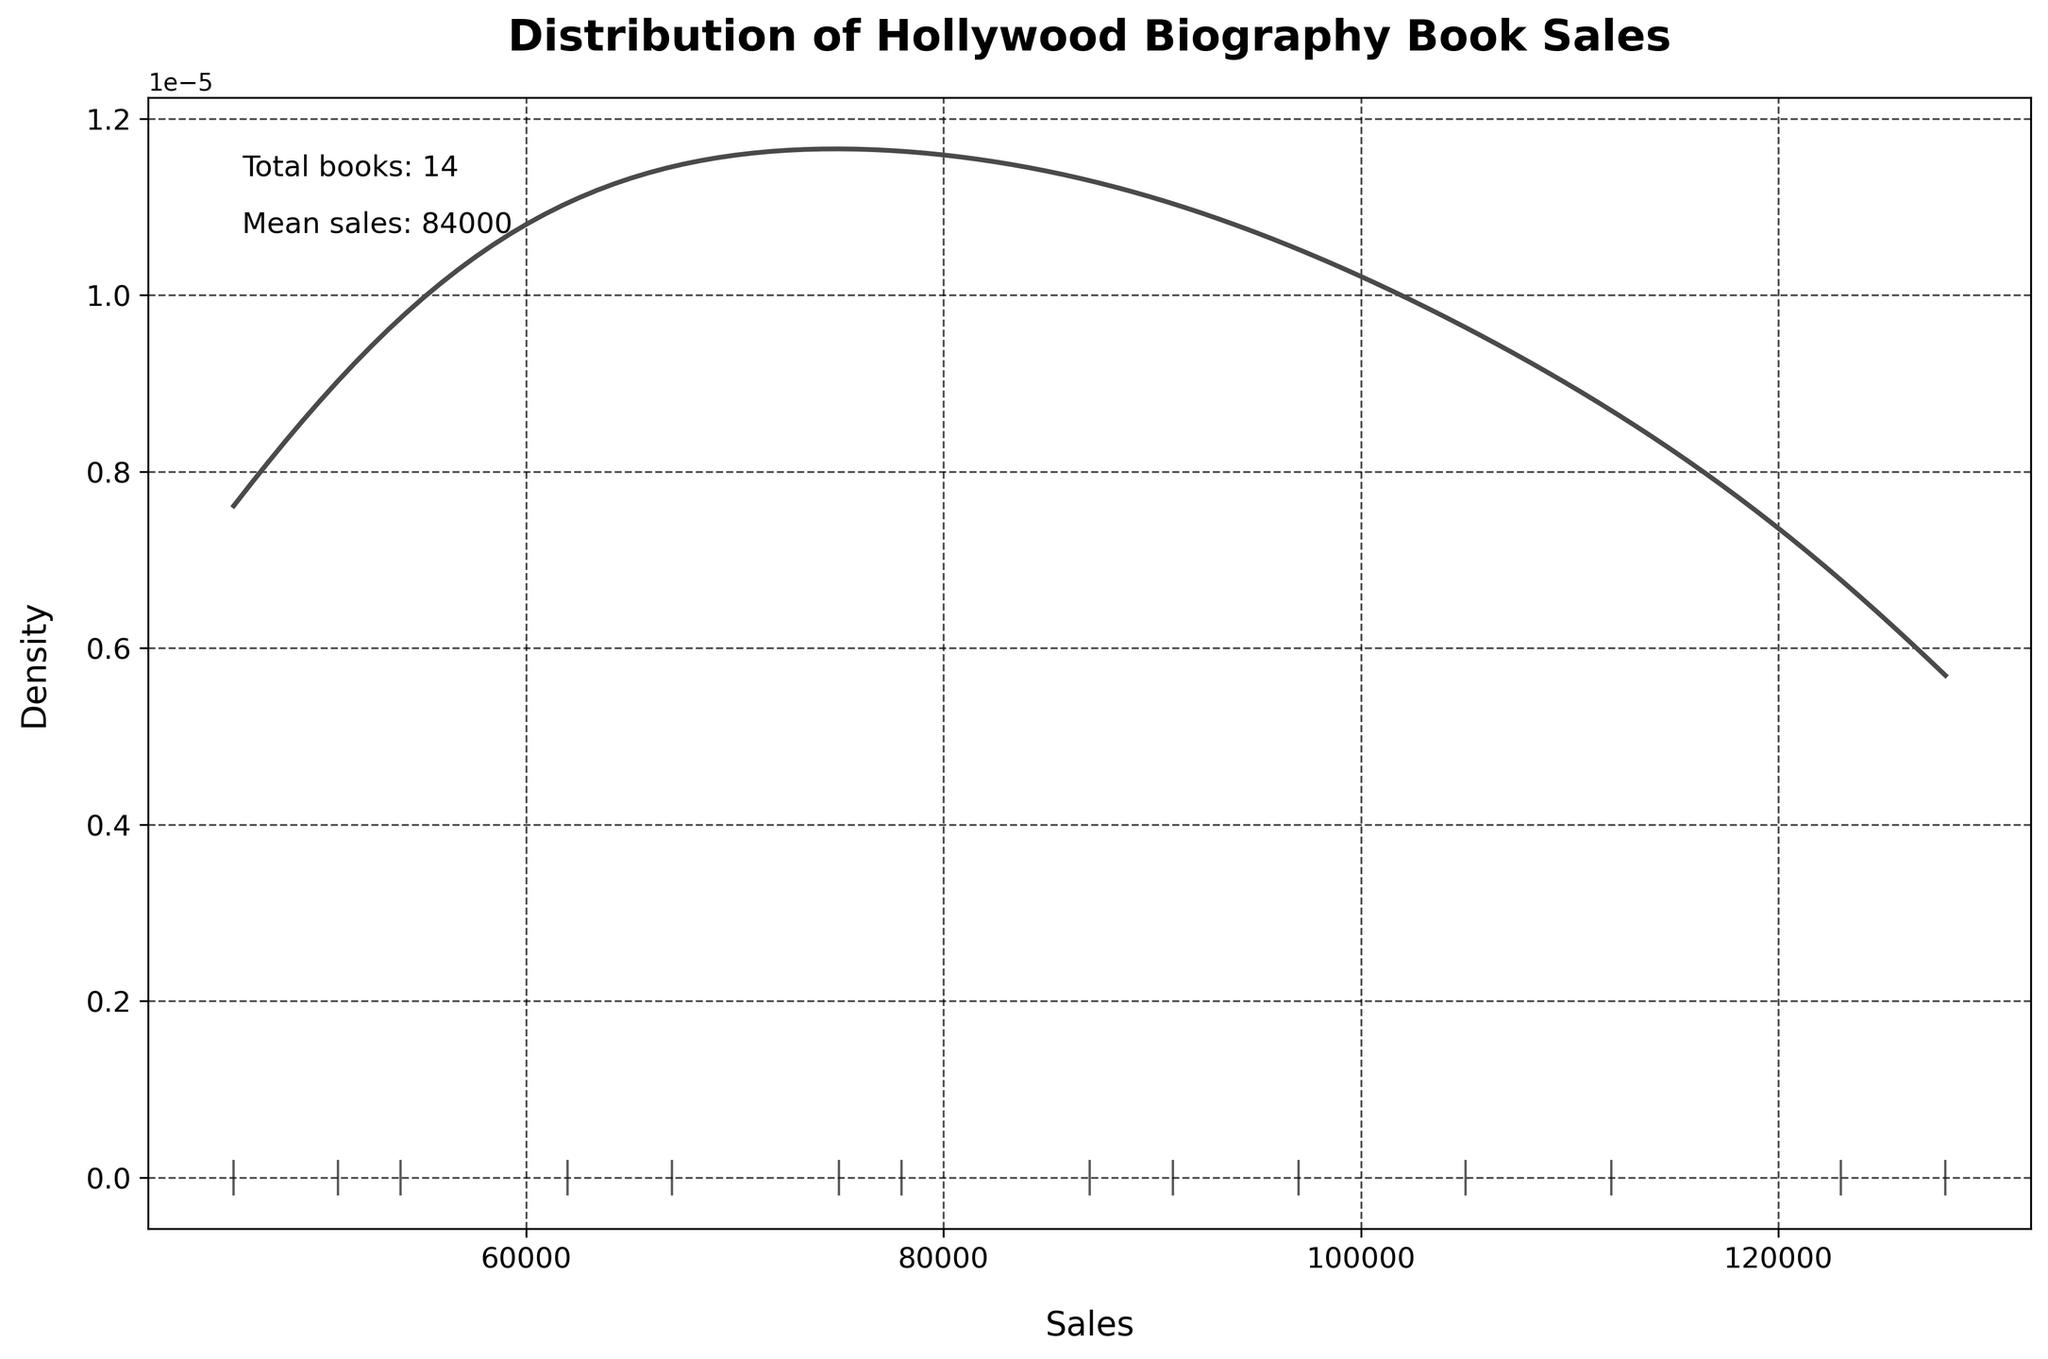How many books are analyzed in the plot? The plot includes a text annotation that states "Total books: 14." This indicates the total number of books.
Answer: 14 What is the mean sales figure for the books? The plot includes a text annotation that states "Mean sales: 84643." This shows the calculated mean of the sales figures.
Answer: 84643 Which book had the highest sales figure? By looking at the rug plot of sales data points, the highest sales figure corresponds to "Marilyn Monroe: The Biography," which stands out on the sales axis.
Answer: "Marilyn Monroe: The Biography" What is the range of the sales data? The plot's x-axis shows the range of sales figures from approximately 46000 to 128000, which can be identified by the rug plot markers.
Answer: 46000 to 128000 Compared to others, how common are sales figures around 100,000? The peak density shown in the KDE plot around 100,000 indicates sales figures around this value are relatively common.
Answer: Relatively common Which year has the least representation in the dataset? From the table data, only one book ("Spencer Tracy: A Biography") is from 2011, indicating this year has the least representation.
Answer: 2011 How does the peak height of the KDE compare near the mean sales figure? The text annotation states the mean sales is around 84643. The KDE plot has a noticeable peak close to this sales figure, indicating many sales figures are near the mean.
Answer: Close to the mean How much higher is the peak sales figure compared to the mean? The highest sales figure is 128000, while the mean sales figure is 84643. The difference is 128000 - 84643 = 43357.
Answer: 43357 Which two books, based on their titles, seem to have sold the second most? By cross-referencing sales data with the KDE and rug plots, "Lauren Bacall: By Myself" at 128000 and "Marilyn Monroe: The Biography" at 123000 stand out. Though Lauren Bacall's biography has the highest sales, the question asks for the second most, which is "Marilyn Monroe: The Biography."
Answer: "Marilyn Monroe: The Biography" and "Audrey Hepburn: An Elegant Spirit" Do sales figures span more than five decades? The years range from 1974 to 2011, spanning over 37 years. This covers more than three decades but less than four.
Answer: No 